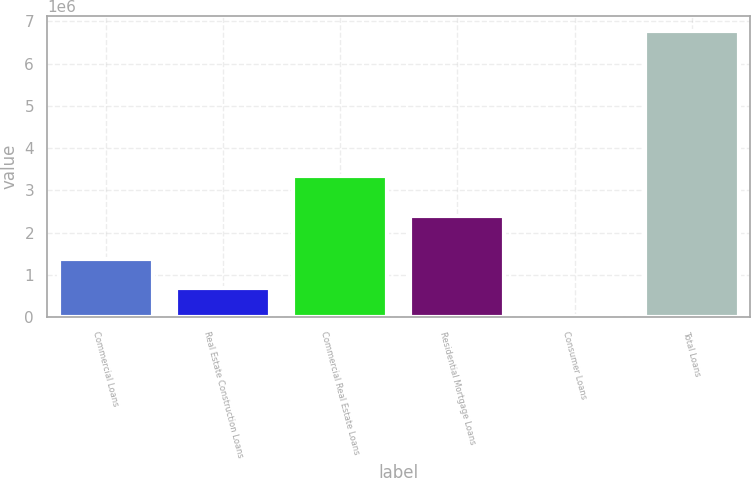<chart> <loc_0><loc_0><loc_500><loc_500><bar_chart><fcel>Commercial Loans<fcel>Real Estate Construction Loans<fcel>Commercial Real Estate Loans<fcel>Residential Mortgage Loans<fcel>Consumer Loans<fcel>Total Loans<nl><fcel>1.3745e+06<fcel>698658<fcel>3.34399e+06<fcel>2.39882e+06<fcel>22816<fcel>6.78124e+06<nl></chart> 